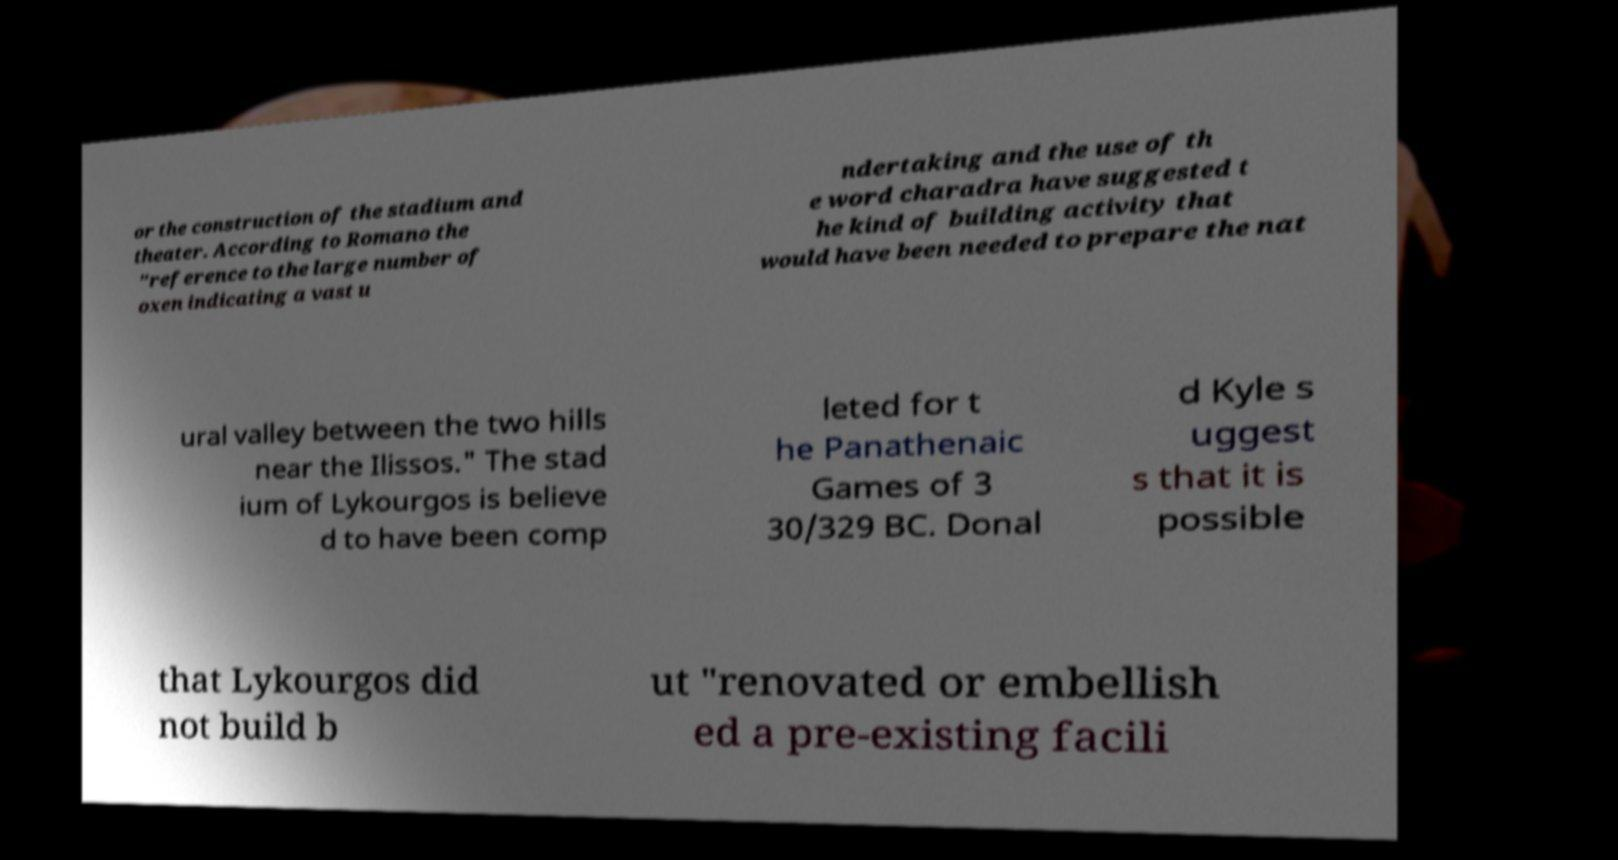Could you extract and type out the text from this image? or the construction of the stadium and theater. According to Romano the "reference to the large number of oxen indicating a vast u ndertaking and the use of th e word charadra have suggested t he kind of building activity that would have been needed to prepare the nat ural valley between the two hills near the Ilissos." The stad ium of Lykourgos is believe d to have been comp leted for t he Panathenaic Games of 3 30/329 BC. Donal d Kyle s uggest s that it is possible that Lykourgos did not build b ut "renovated or embellish ed a pre-existing facili 